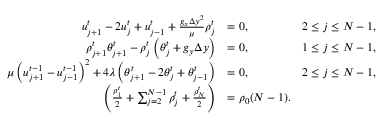<formula> <loc_0><loc_0><loc_500><loc_500>\begin{array} { r l r } { u _ { j + 1 } ^ { t } - 2 u _ { j } ^ { t } + u _ { j - 1 } ^ { t } + \frac { g _ { x } \Delta y ^ { 2 } } { \mu } \rho _ { j } ^ { t } } & { = 0 , \quad } & { 2 \leq j \leq N - 1 , } \\ { \rho _ { j + 1 } ^ { t } \theta _ { j + 1 } ^ { t } - \rho _ { j } ^ { t } \left ( \theta _ { j } ^ { t } + g _ { y } \Delta y \right ) } & { = 0 , \quad } & { 1 \leq j \leq N - 1 , } \\ { \mu \left ( u _ { j + 1 } ^ { t - 1 } - u _ { j - 1 } ^ { t - 1 } \right ) ^ { 2 } + 4 \lambda \left ( \theta _ { j + 1 } ^ { t } - 2 \theta _ { j } ^ { t } + \theta _ { j - 1 } ^ { t } \right ) } & { = 0 , \quad } & { 2 \leq j \leq N - 1 , } \\ { \left ( \frac { \rho _ { 1 } ^ { t } } { 2 } + \sum _ { j = 2 } ^ { N - 1 } \rho _ { j } ^ { t } + \frac { \rho _ { N } ^ { t } } { 2 } \right ) } & { = \rho _ { 0 } ( N - 1 ) . } \end{array}</formula> 